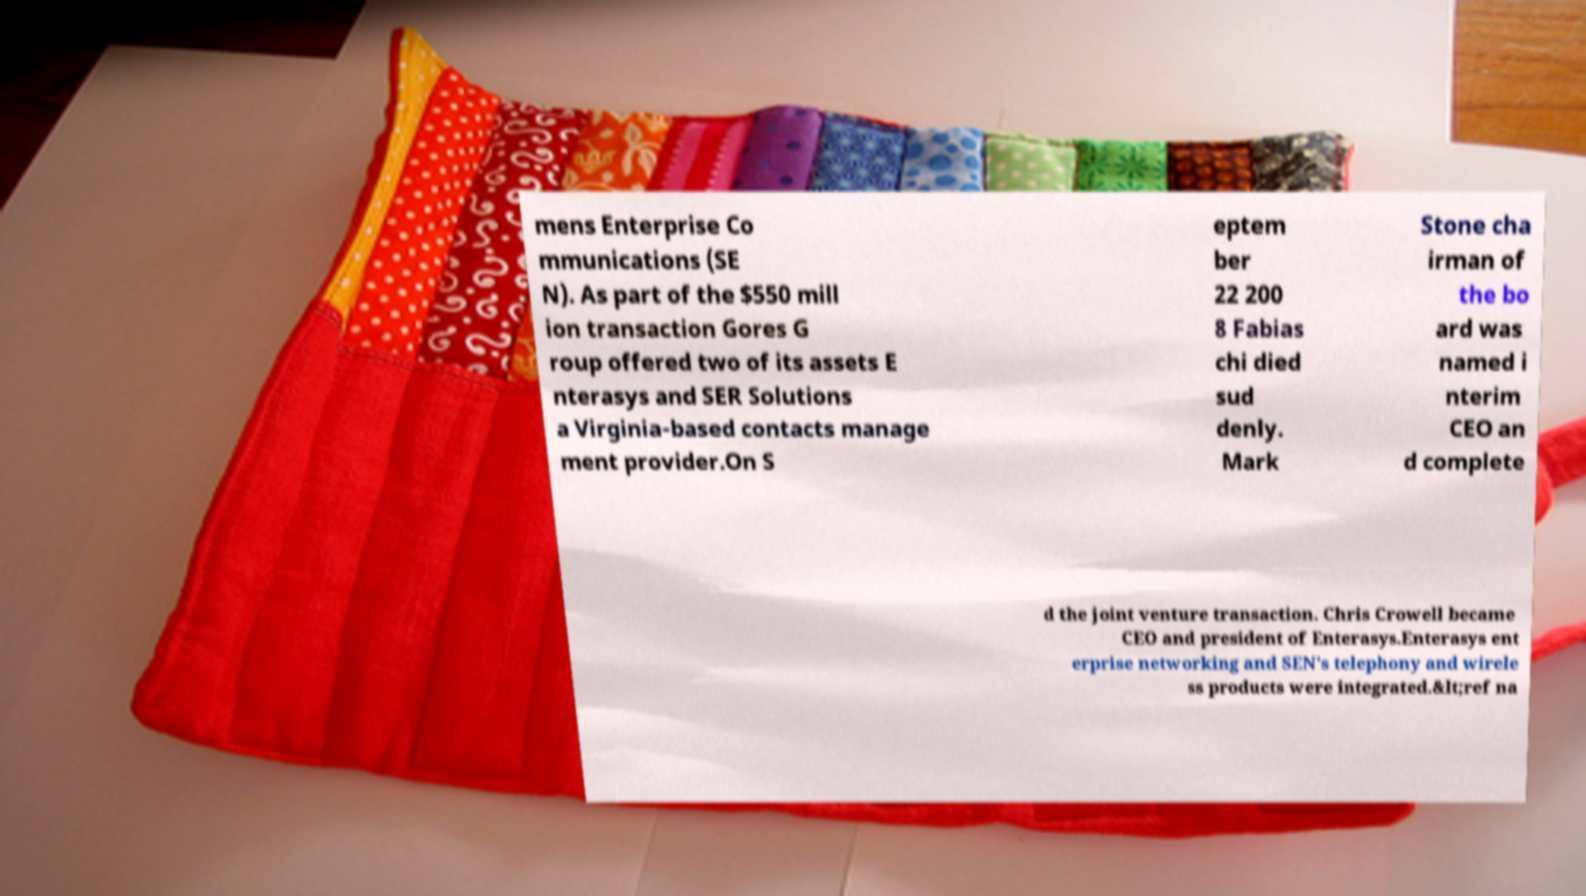Please identify and transcribe the text found in this image. mens Enterprise Co mmunications (SE N). As part of the $550 mill ion transaction Gores G roup offered two of its assets E nterasys and SER Solutions a Virginia-based contacts manage ment provider.On S eptem ber 22 200 8 Fabias chi died sud denly. Mark Stone cha irman of the bo ard was named i nterim CEO an d complete d the joint venture transaction. Chris Crowell became CEO and president of Enterasys.Enterasys ent erprise networking and SEN's telephony and wirele ss products were integrated.&lt;ref na 